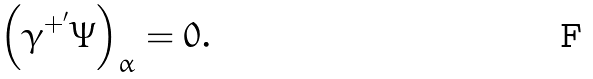<formula> <loc_0><loc_0><loc_500><loc_500>\left ( \gamma ^ { + ^ { \prime } } \Psi \right ) _ { \alpha } = 0 .</formula> 